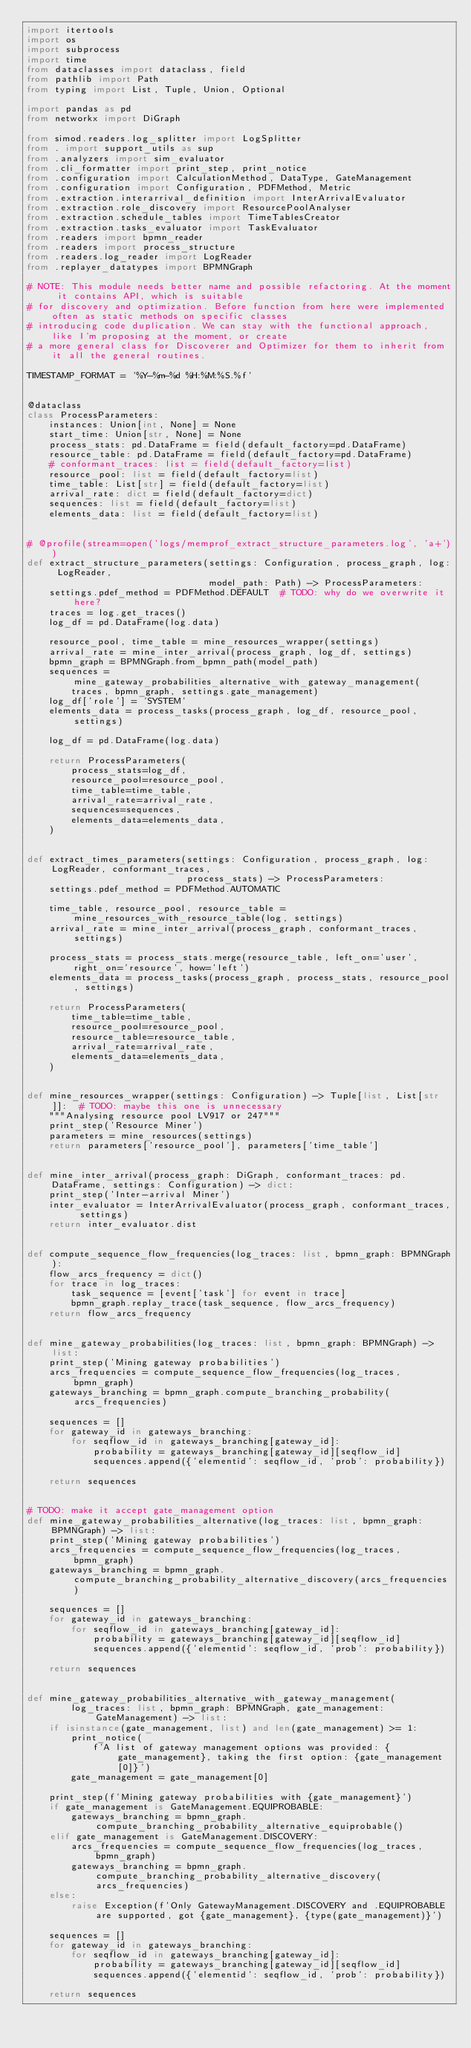Convert code to text. <code><loc_0><loc_0><loc_500><loc_500><_Python_>import itertools
import os
import subprocess
import time
from dataclasses import dataclass, field
from pathlib import Path
from typing import List, Tuple, Union, Optional

import pandas as pd
from networkx import DiGraph

from simod.readers.log_splitter import LogSplitter
from . import support_utils as sup
from .analyzers import sim_evaluator
from .cli_formatter import print_step, print_notice
from .configuration import CalculationMethod, DataType, GateManagement
from .configuration import Configuration, PDFMethod, Metric
from .extraction.interarrival_definition import InterArrivalEvaluator
from .extraction.role_discovery import ResourcePoolAnalyser
from .extraction.schedule_tables import TimeTablesCreator
from .extraction.tasks_evaluator import TaskEvaluator
from .readers import bpmn_reader
from .readers import process_structure
from .readers.log_reader import LogReader
from .replayer_datatypes import BPMNGraph

# NOTE: This module needs better name and possible refactoring. At the moment it contains API, which is suitable
# for discovery and optimization. Before function from here were implemented often as static methods on specific classes
# introducing code duplication. We can stay with the functional approach, like I'm proposing at the moment, or create
# a more general class for Discoverer and Optimizer for them to inherit from it all the general routines.

TIMESTAMP_FORMAT = '%Y-%m-%d %H:%M:%S.%f'


@dataclass
class ProcessParameters:
    instances: Union[int, None] = None
    start_time: Union[str, None] = None
    process_stats: pd.DataFrame = field(default_factory=pd.DataFrame)
    resource_table: pd.DataFrame = field(default_factory=pd.DataFrame)
    # conformant_traces: list = field(default_factory=list)
    resource_pool: list = field(default_factory=list)
    time_table: List[str] = field(default_factory=list)
    arrival_rate: dict = field(default_factory=dict)
    sequences: list = field(default_factory=list)
    elements_data: list = field(default_factory=list)


# @profile(stream=open('logs/memprof_extract_structure_parameters.log', 'a+'))
def extract_structure_parameters(settings: Configuration, process_graph, log: LogReader,
                                 model_path: Path) -> ProcessParameters:
    settings.pdef_method = PDFMethod.DEFAULT  # TODO: why do we overwrite it here?
    traces = log.get_traces()
    log_df = pd.DataFrame(log.data)

    resource_pool, time_table = mine_resources_wrapper(settings)
    arrival_rate = mine_inter_arrival(process_graph, log_df, settings)
    bpmn_graph = BPMNGraph.from_bpmn_path(model_path)
    sequences = mine_gateway_probabilities_alternative_with_gateway_management(
        traces, bpmn_graph, settings.gate_management)
    log_df['role'] = 'SYSTEM'
    elements_data = process_tasks(process_graph, log_df, resource_pool, settings)

    log_df = pd.DataFrame(log.data)

    return ProcessParameters(
        process_stats=log_df,
        resource_pool=resource_pool,
        time_table=time_table,
        arrival_rate=arrival_rate,
        sequences=sequences,
        elements_data=elements_data,
    )


def extract_times_parameters(settings: Configuration, process_graph, log: LogReader, conformant_traces,
                             process_stats) -> ProcessParameters:
    settings.pdef_method = PDFMethod.AUTOMATIC

    time_table, resource_pool, resource_table = mine_resources_with_resource_table(log, settings)
    arrival_rate = mine_inter_arrival(process_graph, conformant_traces, settings)

    process_stats = process_stats.merge(resource_table, left_on='user', right_on='resource', how='left')
    elements_data = process_tasks(process_graph, process_stats, resource_pool, settings)

    return ProcessParameters(
        time_table=time_table,
        resource_pool=resource_pool,
        resource_table=resource_table,
        arrival_rate=arrival_rate,
        elements_data=elements_data,
    )


def mine_resources_wrapper(settings: Configuration) -> Tuple[list, List[str]]:  # TODO: maybe this one is unnecessary
    """Analysing resource pool LV917 or 247"""
    print_step('Resource Miner')
    parameters = mine_resources(settings)
    return parameters['resource_pool'], parameters['time_table']


def mine_inter_arrival(process_graph: DiGraph, conformant_traces: pd.DataFrame, settings: Configuration) -> dict:
    print_step('Inter-arrival Miner')
    inter_evaluator = InterArrivalEvaluator(process_graph, conformant_traces, settings)
    return inter_evaluator.dist


def compute_sequence_flow_frequencies(log_traces: list, bpmn_graph: BPMNGraph):
    flow_arcs_frequency = dict()
    for trace in log_traces:
        task_sequence = [event['task'] for event in trace]
        bpmn_graph.replay_trace(task_sequence, flow_arcs_frequency)
    return flow_arcs_frequency


def mine_gateway_probabilities(log_traces: list, bpmn_graph: BPMNGraph) -> list:
    print_step('Mining gateway probabilities')
    arcs_frequencies = compute_sequence_flow_frequencies(log_traces, bpmn_graph)
    gateways_branching = bpmn_graph.compute_branching_probability(arcs_frequencies)

    sequences = []
    for gateway_id in gateways_branching:
        for seqflow_id in gateways_branching[gateway_id]:
            probability = gateways_branching[gateway_id][seqflow_id]
            sequences.append({'elementid': seqflow_id, 'prob': probability})

    return sequences


# TODO: make it accept gate_management option
def mine_gateway_probabilities_alternative(log_traces: list, bpmn_graph: BPMNGraph) -> list:
    print_step('Mining gateway probabilities')
    arcs_frequencies = compute_sequence_flow_frequencies(log_traces, bpmn_graph)
    gateways_branching = bpmn_graph.compute_branching_probability_alternative_discovery(arcs_frequencies)

    sequences = []
    for gateway_id in gateways_branching:
        for seqflow_id in gateways_branching[gateway_id]:
            probability = gateways_branching[gateway_id][seqflow_id]
            sequences.append({'elementid': seqflow_id, 'prob': probability})

    return sequences


def mine_gateway_probabilities_alternative_with_gateway_management(
        log_traces: list, bpmn_graph: BPMNGraph, gate_management: GateManagement) -> list:
    if isinstance(gate_management, list) and len(gate_management) >= 1:
        print_notice(
            f'A list of gateway management options was provided: {gate_management}, taking the first option: {gate_management[0]}')
        gate_management = gate_management[0]

    print_step(f'Mining gateway probabilities with {gate_management}')
    if gate_management is GateManagement.EQUIPROBABLE:
        gateways_branching = bpmn_graph.compute_branching_probability_alternative_equiprobable()
    elif gate_management is GateManagement.DISCOVERY:
        arcs_frequencies = compute_sequence_flow_frequencies(log_traces, bpmn_graph)
        gateways_branching = bpmn_graph.compute_branching_probability_alternative_discovery(arcs_frequencies)
    else:
        raise Exception(f'Only GatewayManagement.DISCOVERY and .EQUIPROBABLE are supported, got {gate_management}, {type(gate_management)}')

    sequences = []
    for gateway_id in gateways_branching:
        for seqflow_id in gateways_branching[gateway_id]:
            probability = gateways_branching[gateway_id][seqflow_id]
            sequences.append({'elementid': seqflow_id, 'prob': probability})

    return sequences

</code> 